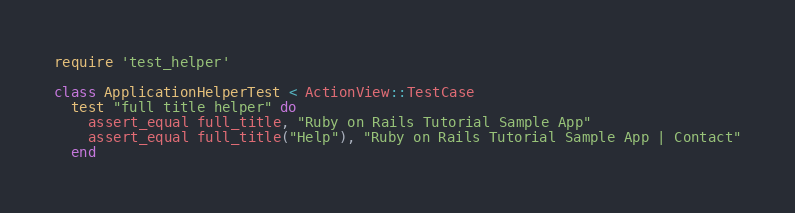Convert code to text. <code><loc_0><loc_0><loc_500><loc_500><_Ruby_>require 'test_helper'

class ApplicationHelperTest < ActionView::TestCase
  test "full title helper" do
    assert_equal full_title, "Ruby on Rails Tutorial Sample App"
    assert_equal full_title("Help"), "Ruby on Rails Tutorial Sample App | Contact"
  end
</code> 